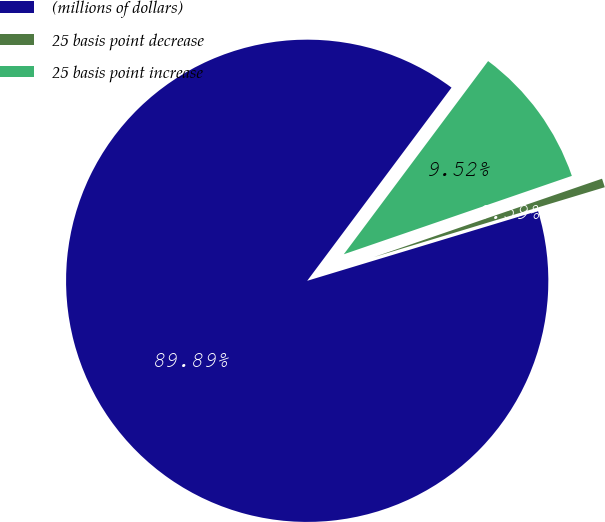<chart> <loc_0><loc_0><loc_500><loc_500><pie_chart><fcel>(millions of dollars)<fcel>25 basis point decrease<fcel>25 basis point increase<nl><fcel>89.89%<fcel>0.59%<fcel>9.52%<nl></chart> 